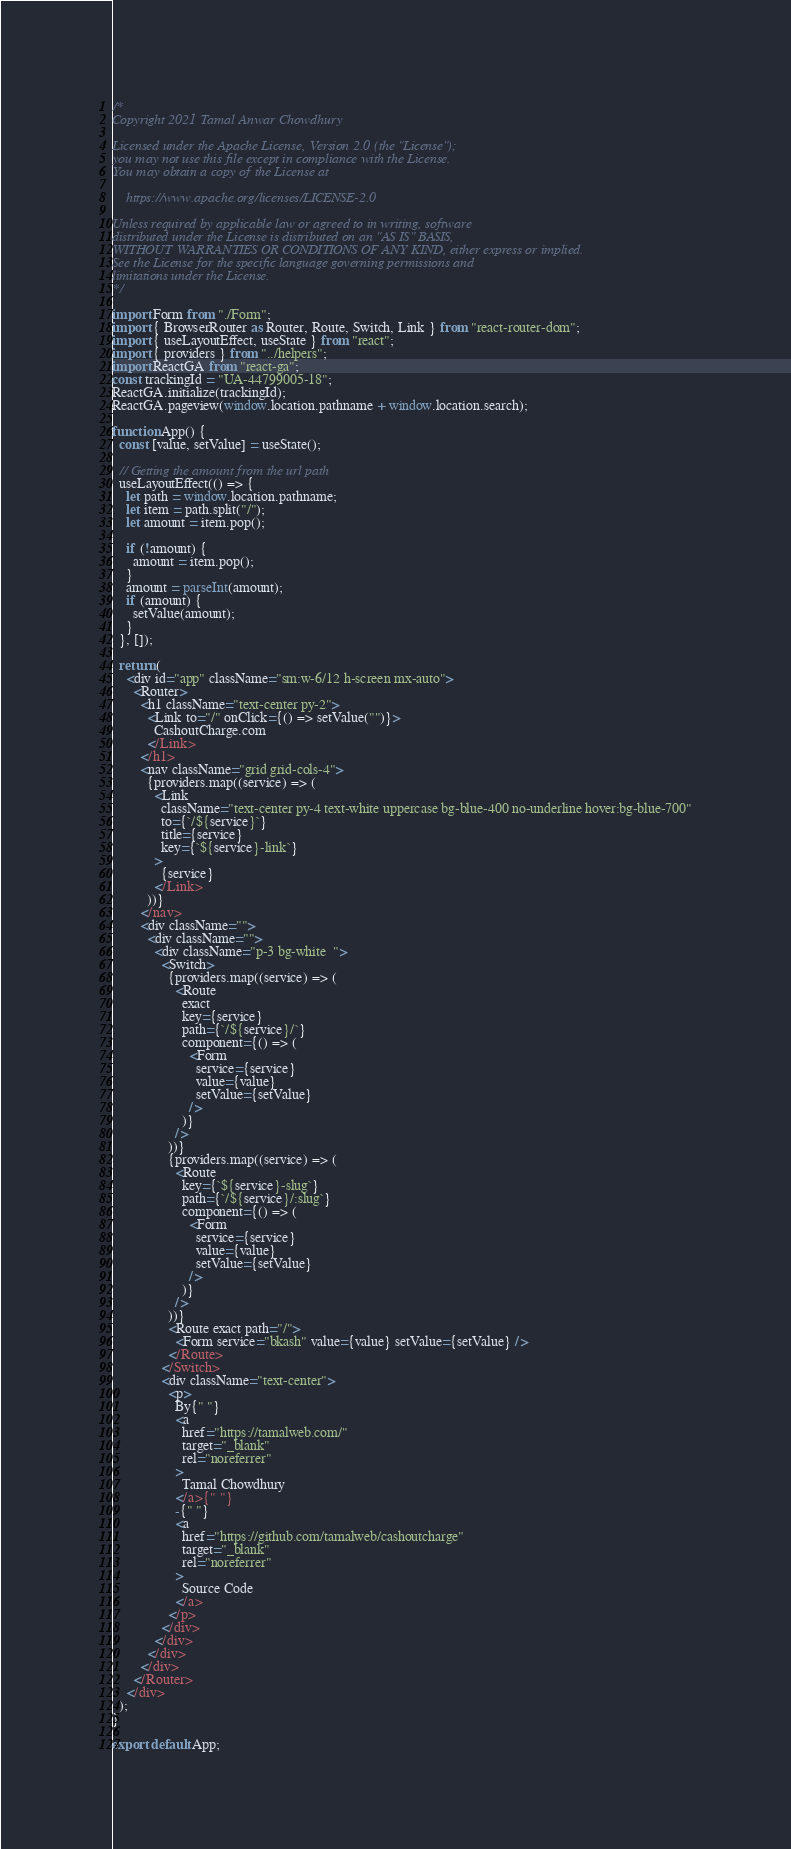Convert code to text. <code><loc_0><loc_0><loc_500><loc_500><_JavaScript_>/*
Copyright 2021 Tamal Anwar Chowdhury

Licensed under the Apache License, Version 2.0 (the "License");
you may not use this file except in compliance with the License.
You may obtain a copy of the License at

    https://www.apache.org/licenses/LICENSE-2.0

Unless required by applicable law or agreed to in writing, software
distributed under the License is distributed on an "AS IS" BASIS,
WITHOUT WARRANTIES OR CONDITIONS OF ANY KIND, either express or implied.
See the License for the specific language governing permissions and
limitations under the License.
*/

import Form from "./Form";
import { BrowserRouter as Router, Route, Switch, Link } from "react-router-dom";
import { useLayoutEffect, useState } from "react";
import { providers } from "../helpers";
import ReactGA from "react-ga";
const trackingId = "UA-44799005-18";
ReactGA.initialize(trackingId);
ReactGA.pageview(window.location.pathname + window.location.search);

function App() {
  const [value, setValue] = useState();

  // Getting the amount from the url path
  useLayoutEffect(() => {
    let path = window.location.pathname;
    let item = path.split("/");
    let amount = item.pop();

    if (!amount) {
      amount = item.pop();
    }
    amount = parseInt(amount);
    if (amount) {
      setValue(amount);
    }
  }, []);

  return (
    <div id="app" className="sm:w-6/12 h-screen mx-auto">
      <Router>
        <h1 className="text-center py-2">
          <Link to="/" onClick={() => setValue("")}>
            CashoutCharge.com
          </Link>
        </h1>
        <nav className="grid grid-cols-4">
          {providers.map((service) => (
            <Link
              className="text-center py-4 text-white uppercase bg-blue-400 no-underline hover:bg-blue-700"
              to={`/${service}`}
              title={service}
              key={`${service}-link`}
            >
              {service}
            </Link>
          ))}
        </nav>
        <div className="">
          <div className="">
            <div className="p-3 bg-white  ">
              <Switch>
                {providers.map((service) => (
                  <Route
                    exact
                    key={service}
                    path={`/${service}/`}
                    component={() => (
                      <Form
                        service={service}
                        value={value}
                        setValue={setValue}
                      />
                    )}
                  />
                ))}
                {providers.map((service) => (
                  <Route
                    key={`${service}-slug`}
                    path={`/${service}/:slug`}
                    component={() => (
                      <Form
                        service={service}
                        value={value}
                        setValue={setValue}
                      />
                    )}
                  />
                ))}
                <Route exact path="/">
                  <Form service="bkash" value={value} setValue={setValue} />
                </Route>
              </Switch>
              <div className="text-center">
                <p>
                  By{" "}
                  <a
                    href="https://tamalweb.com/"
                    target="_blank"
                    rel="noreferrer"
                  >
                    Tamal Chowdhury
                  </a>{" "}
                  -{" "}
                  <a
                    href="https://github.com/tamalweb/cashoutcharge"
                    target="_blank"
                    rel="noreferrer"
                  >
                    Source Code
                  </a>
                </p>
              </div>
            </div>
          </div>
        </div>
      </Router>
    </div>
  );
}

export default App;
</code> 